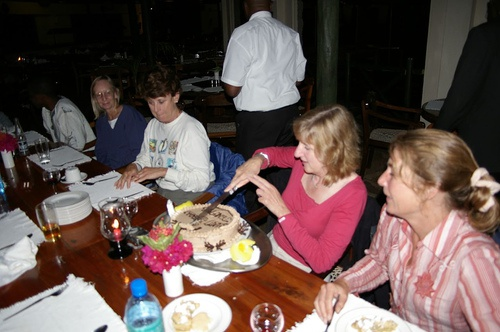Describe the objects in this image and their specific colors. I can see dining table in black, white, maroon, and darkgray tones, people in black, lightpink, gray, lightgray, and darkgray tones, people in black, brown, and tan tones, people in black, darkgray, and lightgray tones, and people in black, lightgray, darkgray, and gray tones in this image. 